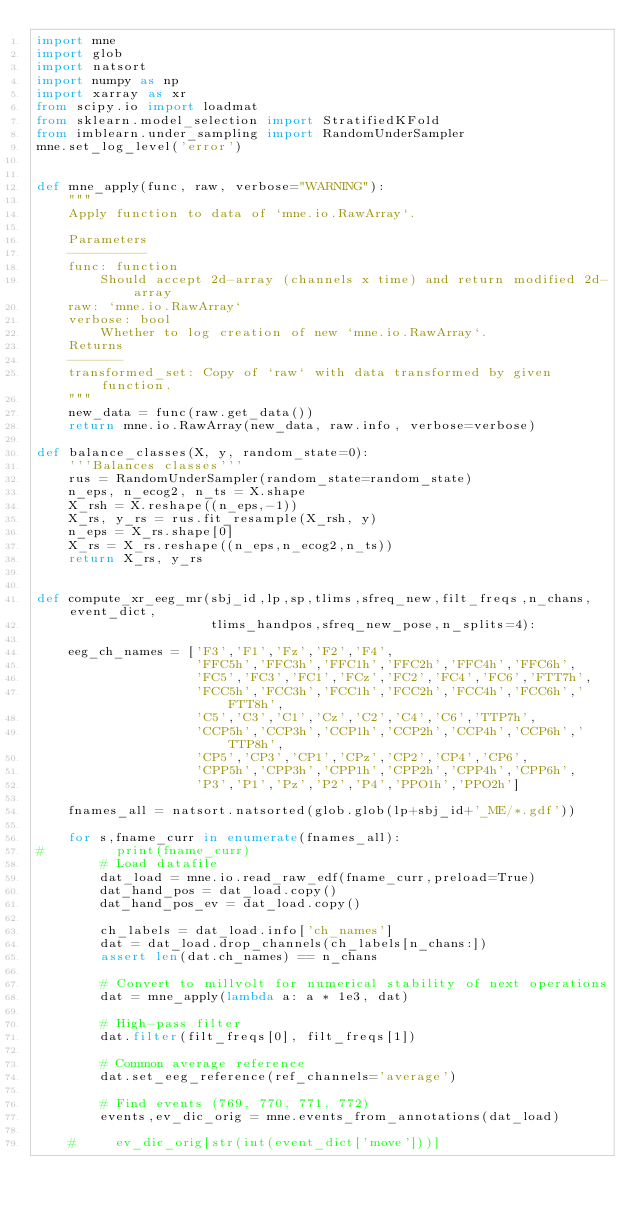Convert code to text. <code><loc_0><loc_0><loc_500><loc_500><_Python_>import mne
import glob
import natsort
import numpy as np
import xarray as xr
from scipy.io import loadmat
from sklearn.model_selection import StratifiedKFold
from imblearn.under_sampling import RandomUnderSampler
mne.set_log_level('error')


def mne_apply(func, raw, verbose="WARNING"):
    """
    Apply function to data of `mne.io.RawArray`.
    
    Parameters
    ----------
    func: function
        Should accept 2d-array (channels x time) and return modified 2d-array
    raw: `mne.io.RawArray`
    verbose: bool
        Whether to log creation of new `mne.io.RawArray`.
    Returns
    -------
    transformed_set: Copy of `raw` with data transformed by given function.
    """
    new_data = func(raw.get_data())
    return mne.io.RawArray(new_data, raw.info, verbose=verbose)

def balance_classes(X, y, random_state=0):
    '''Balances classes'''
    rus = RandomUnderSampler(random_state=random_state)
    n_eps, n_ecog2, n_ts = X.shape
    X_rsh = X.reshape((n_eps,-1))
    X_rs, y_rs = rus.fit_resample(X_rsh, y)
    n_eps = X_rs.shape[0]
    X_rs = X_rs.reshape((n_eps,n_ecog2,n_ts))
    return X_rs, y_rs


def compute_xr_eeg_mr(sbj_id,lp,sp,tlims,sfreq_new,filt_freqs,n_chans,event_dict,
                      tlims_handpos,sfreq_new_pose,n_splits=4):
    
    eeg_ch_names = ['F3','F1','Fz','F2','F4',
                    'FFC5h','FFC3h','FFC1h','FFC2h','FFC4h','FFC6h',
                    'FC5','FC3','FC1','FCz','FC2','FC4','FC6','FTT7h',
                    'FCC5h','FCC3h','FCC1h','FCC2h','FCC4h','FCC6h','FTT8h',
                    'C5','C3','C1','Cz','C2','C4','C6','TTP7h',
                    'CCP5h','CCP3h','CCP1h','CCP2h','CCP4h','CCP6h','TTP8h',
                    'CP5','CP3','CP1','CPz','CP2','CP4','CP6',
                    'CPP5h','CPP3h','CPP1h','CPP2h','CPP4h','CPP6h',
                    'P3','P1','Pz','P2','P4','PPO1h','PPO2h']
    
    fnames_all = natsort.natsorted(glob.glob(lp+sbj_id+'_ME/*.gdf'))

    for s,fname_curr in enumerate(fnames_all):
#         print(fname_curr)
        # Load datafile
        dat_load = mne.io.read_raw_edf(fname_curr,preload=True)
        dat_hand_pos = dat_load.copy()
        dat_hand_pos_ev = dat_load.copy()

        ch_labels = dat_load.info['ch_names']
        dat = dat_load.drop_channels(ch_labels[n_chans:])
        assert len(dat.ch_names) == n_chans

        # Convert to millvolt for numerical stability of next operations
        dat = mne_apply(lambda a: a * 1e3, dat)

        # High-pass filter
        dat.filter(filt_freqs[0], filt_freqs[1])
        
        # Common average reference
        dat.set_eeg_reference(ref_channels='average')

        # Find events (769, 770, 771, 772)
        events,ev_dic_orig = mne.events_from_annotations(dat_load)
        
    #     ev_dic_orig[str(int(event_dict['move']))]
</code> 